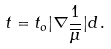Convert formula to latex. <formula><loc_0><loc_0><loc_500><loc_500>t = t _ { o } | \nabla \frac { 1 } { \overline { \mu } } | d \, .</formula> 